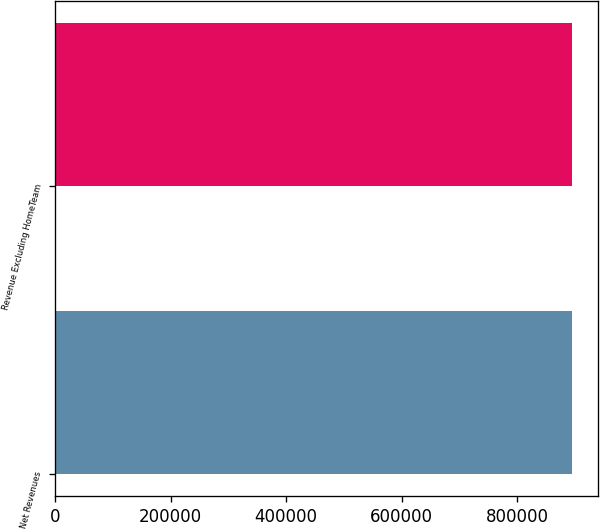Convert chart. <chart><loc_0><loc_0><loc_500><loc_500><bar_chart><fcel>Net Revenues<fcel>Revenue Excluding HomeTeam<nl><fcel>894920<fcel>894920<nl></chart> 